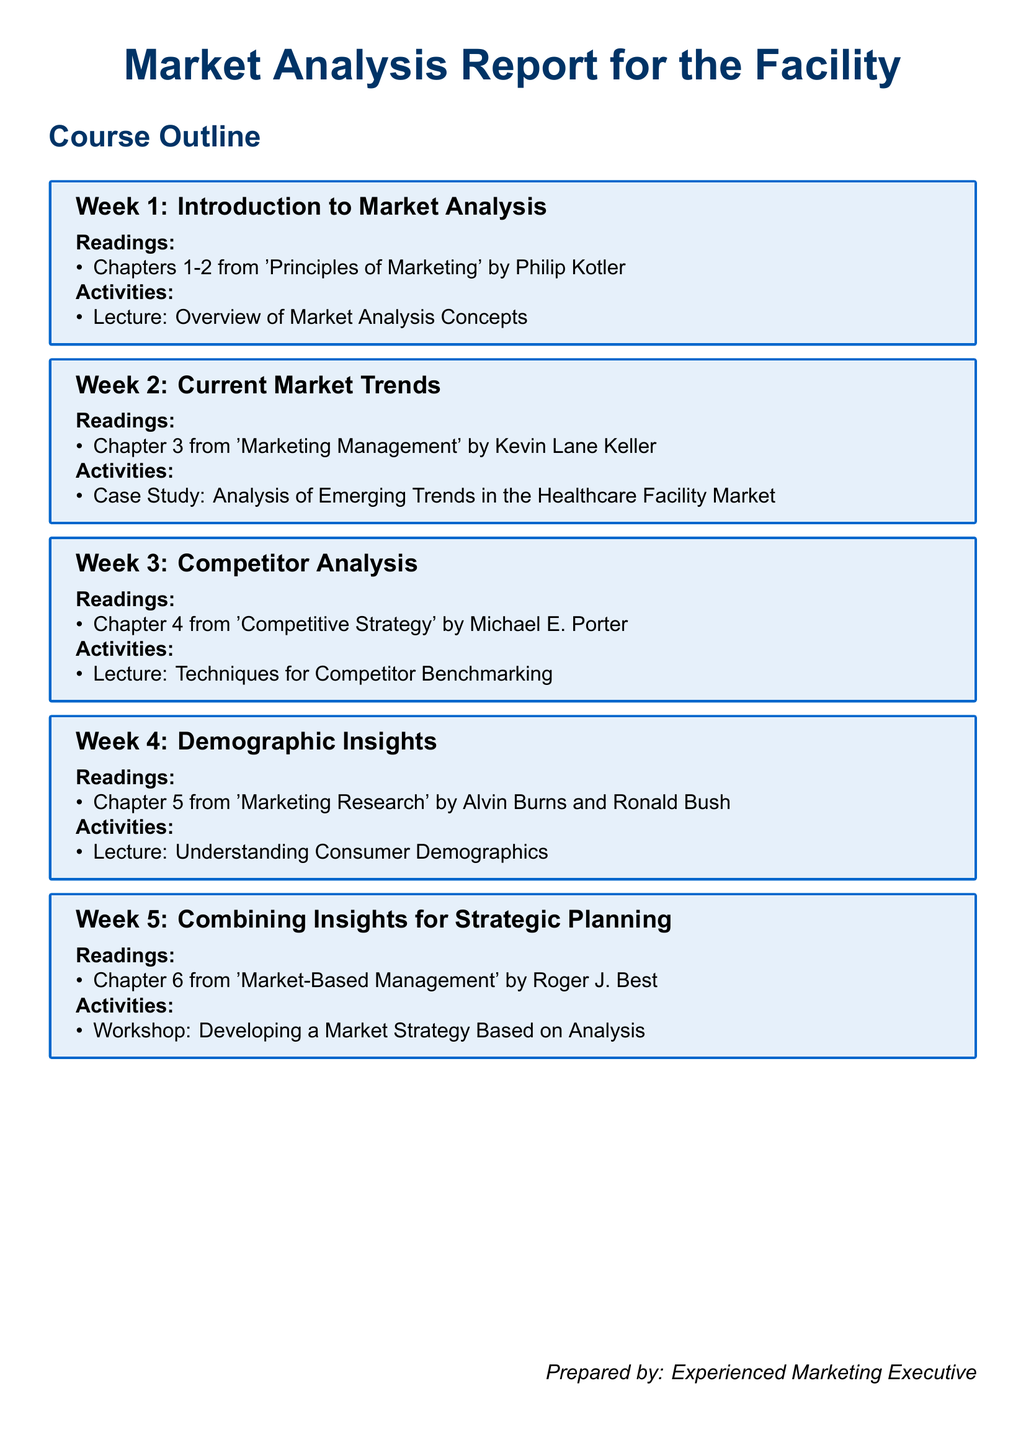What is the title of the document? The title is prominently displayed at the center of the document.
Answer: Market Analysis Report for the Facility What is the focus of Week 2? Week 2 is specifically outlined to address current market trends in the syllabus.
Answer: Current Market Trends Which chapter from 'Competitive Strategy' is covered in Week 3? The syllabus specifies the chapter number from the given book for Week 3.
Answer: Chapter 4 Who is the author of 'Principles of Marketing'? The syllabus references the author of the book used in Week 1.
Answer: Philip Kotler What type of activity is scheduled for Week 5? The activity format is specified for the final week and indicates a participatory approach.
Answer: Workshop Which week discusses consumer demographics? The week dedicated to understanding demographics is clearly labeled in the document.
Answer: Week 4 What is the main subject of the case study in Week 2? The specific focus of the case study is indicated in the activities section for Week 2.
Answer: Emerging Trends in the Healthcare Facility Market What publishing year is associated with 'Marketing Management'? The syllabus does not provide a specific year, but the book's information allows inference.
Answer: Not stated 